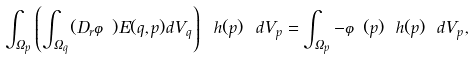Convert formula to latex. <formula><loc_0><loc_0><loc_500><loc_500>\int _ { \Omega _ { p } } \left ( \int _ { \Omega _ { q } } ( D _ { r } \varphi ) E ( q , p ) d V _ { q } \right ) \ h ( p ) \ d V _ { p } = \int _ { \Omega _ { p } } - \varphi ( p ) \ h ( p ) \ d V _ { p } ,</formula> 